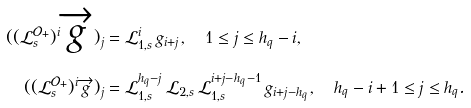Convert formula to latex. <formula><loc_0><loc_0><loc_500><loc_500>( ( \mathcal { L } _ { s } ^ { \mathcal { O } _ { + } } ) ^ { i } \overrightarrow { g } ) _ { j } & = \mathcal { L } _ { 1 , s } ^ { i } \, g _ { i + j } , \quad 1 \leq j \leq h _ { q } - i , \\ ( ( \mathcal { L } _ { s } ^ { \mathcal { O } _ { + } } ) ^ { i } \overrightarrow { g } ) _ { j } & = \mathcal { L } _ { 1 , s } ^ { h _ { q } - j } \, \mathcal { L } _ { 2 , s } \, \mathcal { L } _ { 1 , s } ^ { i + j - h _ { q } - 1 } \, g _ { i + j - h _ { q } } , \quad h _ { q } - i + 1 \leq j \leq h _ { q } .</formula> 